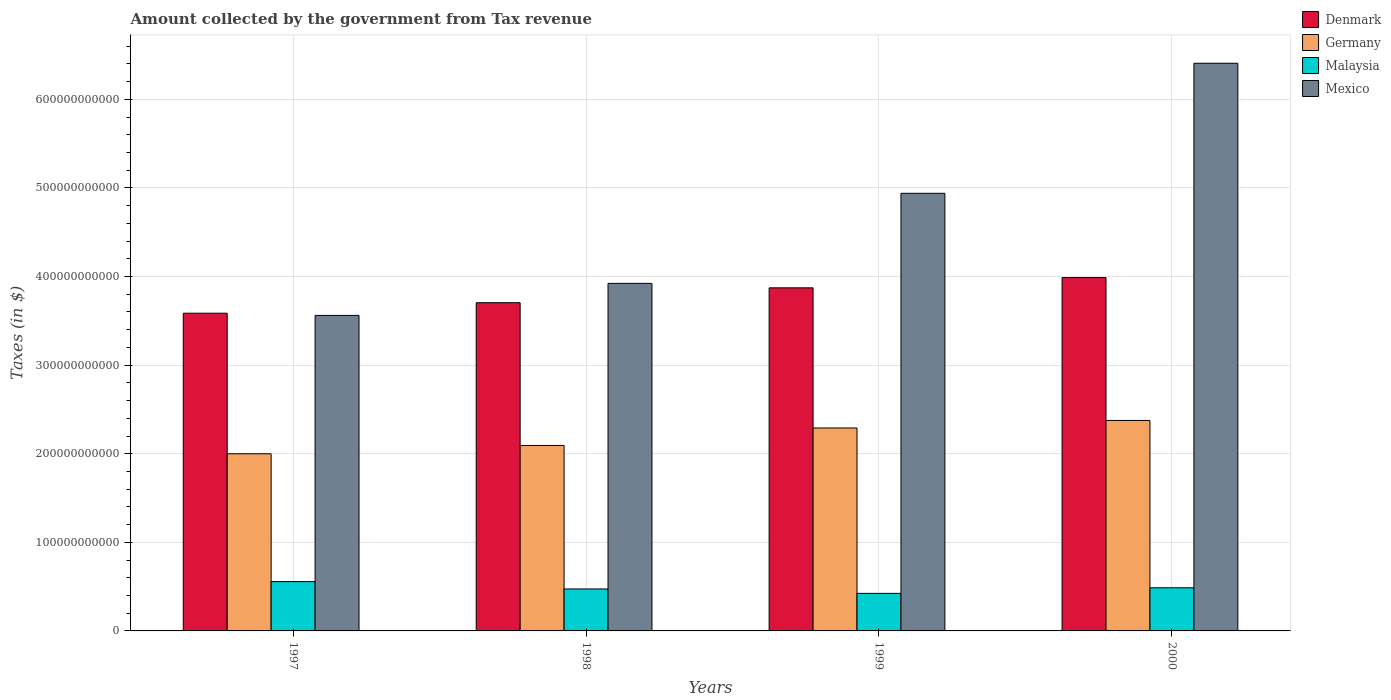How many groups of bars are there?
Your answer should be very brief. 4. Are the number of bars per tick equal to the number of legend labels?
Your answer should be very brief. Yes. Are the number of bars on each tick of the X-axis equal?
Give a very brief answer. Yes. How many bars are there on the 2nd tick from the right?
Provide a succinct answer. 4. What is the amount collected by the government from tax revenue in Mexico in 1997?
Your response must be concise. 3.56e+11. Across all years, what is the maximum amount collected by the government from tax revenue in Malaysia?
Give a very brief answer. 5.57e+1. Across all years, what is the minimum amount collected by the government from tax revenue in Malaysia?
Your answer should be compact. 4.24e+1. In which year was the amount collected by the government from tax revenue in Mexico minimum?
Ensure brevity in your answer.  1997. What is the total amount collected by the government from tax revenue in Mexico in the graph?
Your answer should be very brief. 1.88e+12. What is the difference between the amount collected by the government from tax revenue in Denmark in 1998 and that in 1999?
Provide a succinct answer. -1.68e+1. What is the difference between the amount collected by the government from tax revenue in Denmark in 1997 and the amount collected by the government from tax revenue in Malaysia in 1999?
Your response must be concise. 3.16e+11. What is the average amount collected by the government from tax revenue in Denmark per year?
Your answer should be very brief. 3.79e+11. In the year 1997, what is the difference between the amount collected by the government from tax revenue in Malaysia and amount collected by the government from tax revenue in Denmark?
Your answer should be very brief. -3.03e+11. What is the ratio of the amount collected by the government from tax revenue in Mexico in 1998 to that in 2000?
Offer a very short reply. 0.61. Is the difference between the amount collected by the government from tax revenue in Malaysia in 1997 and 2000 greater than the difference between the amount collected by the government from tax revenue in Denmark in 1997 and 2000?
Offer a terse response. Yes. What is the difference between the highest and the second highest amount collected by the government from tax revenue in Mexico?
Ensure brevity in your answer.  1.47e+11. What is the difference between the highest and the lowest amount collected by the government from tax revenue in Germany?
Provide a short and direct response. 3.76e+1. In how many years, is the amount collected by the government from tax revenue in Denmark greater than the average amount collected by the government from tax revenue in Denmark taken over all years?
Keep it short and to the point. 2. Is the sum of the amount collected by the government from tax revenue in Malaysia in 1999 and 2000 greater than the maximum amount collected by the government from tax revenue in Mexico across all years?
Offer a very short reply. No. What does the 4th bar from the left in 1998 represents?
Keep it short and to the point. Mexico. What does the 2nd bar from the right in 2000 represents?
Make the answer very short. Malaysia. Is it the case that in every year, the sum of the amount collected by the government from tax revenue in Denmark and amount collected by the government from tax revenue in Germany is greater than the amount collected by the government from tax revenue in Mexico?
Your answer should be compact. No. Are all the bars in the graph horizontal?
Offer a very short reply. No. What is the difference between two consecutive major ticks on the Y-axis?
Your answer should be compact. 1.00e+11. Does the graph contain grids?
Your response must be concise. Yes. Where does the legend appear in the graph?
Provide a succinct answer. Top right. How many legend labels are there?
Provide a succinct answer. 4. How are the legend labels stacked?
Give a very brief answer. Vertical. What is the title of the graph?
Provide a short and direct response. Amount collected by the government from Tax revenue. Does "Australia" appear as one of the legend labels in the graph?
Provide a short and direct response. No. What is the label or title of the X-axis?
Offer a very short reply. Years. What is the label or title of the Y-axis?
Your response must be concise. Taxes (in $). What is the Taxes (in $) in Denmark in 1997?
Offer a terse response. 3.59e+11. What is the Taxes (in $) of Germany in 1997?
Your answer should be very brief. 2.00e+11. What is the Taxes (in $) of Malaysia in 1997?
Give a very brief answer. 5.57e+1. What is the Taxes (in $) of Mexico in 1997?
Your answer should be compact. 3.56e+11. What is the Taxes (in $) in Denmark in 1998?
Your answer should be very brief. 3.70e+11. What is the Taxes (in $) in Germany in 1998?
Your answer should be very brief. 2.09e+11. What is the Taxes (in $) in Malaysia in 1998?
Give a very brief answer. 4.74e+1. What is the Taxes (in $) in Mexico in 1998?
Provide a succinct answer. 3.92e+11. What is the Taxes (in $) of Denmark in 1999?
Your answer should be compact. 3.87e+11. What is the Taxes (in $) in Germany in 1999?
Provide a short and direct response. 2.29e+11. What is the Taxes (in $) of Malaysia in 1999?
Your response must be concise. 4.24e+1. What is the Taxes (in $) in Mexico in 1999?
Your answer should be compact. 4.94e+11. What is the Taxes (in $) in Denmark in 2000?
Ensure brevity in your answer.  3.99e+11. What is the Taxes (in $) of Germany in 2000?
Offer a terse response. 2.38e+11. What is the Taxes (in $) in Malaysia in 2000?
Provide a succinct answer. 4.87e+1. What is the Taxes (in $) of Mexico in 2000?
Make the answer very short. 6.41e+11. Across all years, what is the maximum Taxes (in $) of Denmark?
Provide a succinct answer. 3.99e+11. Across all years, what is the maximum Taxes (in $) in Germany?
Your answer should be very brief. 2.38e+11. Across all years, what is the maximum Taxes (in $) in Malaysia?
Provide a short and direct response. 5.57e+1. Across all years, what is the maximum Taxes (in $) in Mexico?
Give a very brief answer. 6.41e+11. Across all years, what is the minimum Taxes (in $) in Denmark?
Your response must be concise. 3.59e+11. Across all years, what is the minimum Taxes (in $) of Germany?
Your answer should be compact. 2.00e+11. Across all years, what is the minimum Taxes (in $) in Malaysia?
Provide a short and direct response. 4.24e+1. Across all years, what is the minimum Taxes (in $) of Mexico?
Ensure brevity in your answer.  3.56e+11. What is the total Taxes (in $) in Denmark in the graph?
Give a very brief answer. 1.52e+12. What is the total Taxes (in $) in Germany in the graph?
Offer a terse response. 8.76e+11. What is the total Taxes (in $) in Malaysia in the graph?
Provide a succinct answer. 1.94e+11. What is the total Taxes (in $) in Mexico in the graph?
Provide a succinct answer. 1.88e+12. What is the difference between the Taxes (in $) of Denmark in 1997 and that in 1998?
Offer a terse response. -1.19e+1. What is the difference between the Taxes (in $) of Germany in 1997 and that in 1998?
Keep it short and to the point. -9.34e+09. What is the difference between the Taxes (in $) in Malaysia in 1997 and that in 1998?
Offer a terse response. 8.28e+09. What is the difference between the Taxes (in $) in Mexico in 1997 and that in 1998?
Your answer should be very brief. -3.62e+1. What is the difference between the Taxes (in $) in Denmark in 1997 and that in 1999?
Keep it short and to the point. -2.86e+1. What is the difference between the Taxes (in $) in Germany in 1997 and that in 1999?
Give a very brief answer. -2.91e+1. What is the difference between the Taxes (in $) in Malaysia in 1997 and that in 1999?
Your answer should be compact. 1.33e+1. What is the difference between the Taxes (in $) of Mexico in 1997 and that in 1999?
Provide a short and direct response. -1.38e+11. What is the difference between the Taxes (in $) in Denmark in 1997 and that in 2000?
Offer a very short reply. -4.02e+1. What is the difference between the Taxes (in $) in Germany in 1997 and that in 2000?
Provide a succinct answer. -3.76e+1. What is the difference between the Taxes (in $) of Malaysia in 1997 and that in 2000?
Give a very brief answer. 6.96e+09. What is the difference between the Taxes (in $) in Mexico in 1997 and that in 2000?
Your answer should be compact. -2.85e+11. What is the difference between the Taxes (in $) in Denmark in 1998 and that in 1999?
Make the answer very short. -1.68e+1. What is the difference between the Taxes (in $) of Germany in 1998 and that in 1999?
Offer a terse response. -1.98e+1. What is the difference between the Taxes (in $) of Malaysia in 1998 and that in 1999?
Ensure brevity in your answer.  5.00e+09. What is the difference between the Taxes (in $) of Mexico in 1998 and that in 1999?
Give a very brief answer. -1.02e+11. What is the difference between the Taxes (in $) of Denmark in 1998 and that in 2000?
Provide a succinct answer. -2.84e+1. What is the difference between the Taxes (in $) in Germany in 1998 and that in 2000?
Give a very brief answer. -2.83e+1. What is the difference between the Taxes (in $) in Malaysia in 1998 and that in 2000?
Offer a very short reply. -1.32e+09. What is the difference between the Taxes (in $) in Mexico in 1998 and that in 2000?
Keep it short and to the point. -2.48e+11. What is the difference between the Taxes (in $) in Denmark in 1999 and that in 2000?
Your answer should be compact. -1.16e+1. What is the difference between the Taxes (in $) of Germany in 1999 and that in 2000?
Keep it short and to the point. -8.50e+09. What is the difference between the Taxes (in $) in Malaysia in 1999 and that in 2000?
Provide a short and direct response. -6.32e+09. What is the difference between the Taxes (in $) of Mexico in 1999 and that in 2000?
Offer a very short reply. -1.47e+11. What is the difference between the Taxes (in $) of Denmark in 1997 and the Taxes (in $) of Germany in 1998?
Offer a terse response. 1.49e+11. What is the difference between the Taxes (in $) in Denmark in 1997 and the Taxes (in $) in Malaysia in 1998?
Your response must be concise. 3.11e+11. What is the difference between the Taxes (in $) of Denmark in 1997 and the Taxes (in $) of Mexico in 1998?
Your response must be concise. -3.37e+1. What is the difference between the Taxes (in $) in Germany in 1997 and the Taxes (in $) in Malaysia in 1998?
Provide a succinct answer. 1.53e+11. What is the difference between the Taxes (in $) in Germany in 1997 and the Taxes (in $) in Mexico in 1998?
Ensure brevity in your answer.  -1.92e+11. What is the difference between the Taxes (in $) of Malaysia in 1997 and the Taxes (in $) of Mexico in 1998?
Your answer should be compact. -3.37e+11. What is the difference between the Taxes (in $) of Denmark in 1997 and the Taxes (in $) of Germany in 1999?
Ensure brevity in your answer.  1.30e+11. What is the difference between the Taxes (in $) of Denmark in 1997 and the Taxes (in $) of Malaysia in 1999?
Give a very brief answer. 3.16e+11. What is the difference between the Taxes (in $) of Denmark in 1997 and the Taxes (in $) of Mexico in 1999?
Your answer should be compact. -1.35e+11. What is the difference between the Taxes (in $) of Germany in 1997 and the Taxes (in $) of Malaysia in 1999?
Give a very brief answer. 1.58e+11. What is the difference between the Taxes (in $) of Germany in 1997 and the Taxes (in $) of Mexico in 1999?
Your answer should be very brief. -2.94e+11. What is the difference between the Taxes (in $) in Malaysia in 1997 and the Taxes (in $) in Mexico in 1999?
Your answer should be compact. -4.38e+11. What is the difference between the Taxes (in $) of Denmark in 1997 and the Taxes (in $) of Germany in 2000?
Your answer should be very brief. 1.21e+11. What is the difference between the Taxes (in $) of Denmark in 1997 and the Taxes (in $) of Malaysia in 2000?
Ensure brevity in your answer.  3.10e+11. What is the difference between the Taxes (in $) in Denmark in 1997 and the Taxes (in $) in Mexico in 2000?
Provide a short and direct response. -2.82e+11. What is the difference between the Taxes (in $) of Germany in 1997 and the Taxes (in $) of Malaysia in 2000?
Offer a terse response. 1.51e+11. What is the difference between the Taxes (in $) in Germany in 1997 and the Taxes (in $) in Mexico in 2000?
Give a very brief answer. -4.41e+11. What is the difference between the Taxes (in $) of Malaysia in 1997 and the Taxes (in $) of Mexico in 2000?
Offer a very short reply. -5.85e+11. What is the difference between the Taxes (in $) in Denmark in 1998 and the Taxes (in $) in Germany in 1999?
Give a very brief answer. 1.41e+11. What is the difference between the Taxes (in $) of Denmark in 1998 and the Taxes (in $) of Malaysia in 1999?
Provide a succinct answer. 3.28e+11. What is the difference between the Taxes (in $) in Denmark in 1998 and the Taxes (in $) in Mexico in 1999?
Keep it short and to the point. -1.23e+11. What is the difference between the Taxes (in $) in Germany in 1998 and the Taxes (in $) in Malaysia in 1999?
Your answer should be compact. 1.67e+11. What is the difference between the Taxes (in $) of Germany in 1998 and the Taxes (in $) of Mexico in 1999?
Ensure brevity in your answer.  -2.85e+11. What is the difference between the Taxes (in $) of Malaysia in 1998 and the Taxes (in $) of Mexico in 1999?
Make the answer very short. -4.47e+11. What is the difference between the Taxes (in $) in Denmark in 1998 and the Taxes (in $) in Germany in 2000?
Provide a short and direct response. 1.33e+11. What is the difference between the Taxes (in $) in Denmark in 1998 and the Taxes (in $) in Malaysia in 2000?
Your response must be concise. 3.22e+11. What is the difference between the Taxes (in $) in Denmark in 1998 and the Taxes (in $) in Mexico in 2000?
Your answer should be compact. -2.70e+11. What is the difference between the Taxes (in $) in Germany in 1998 and the Taxes (in $) in Malaysia in 2000?
Provide a succinct answer. 1.61e+11. What is the difference between the Taxes (in $) of Germany in 1998 and the Taxes (in $) of Mexico in 2000?
Your answer should be compact. -4.31e+11. What is the difference between the Taxes (in $) of Malaysia in 1998 and the Taxes (in $) of Mexico in 2000?
Keep it short and to the point. -5.93e+11. What is the difference between the Taxes (in $) in Denmark in 1999 and the Taxes (in $) in Germany in 2000?
Give a very brief answer. 1.50e+11. What is the difference between the Taxes (in $) of Denmark in 1999 and the Taxes (in $) of Malaysia in 2000?
Provide a succinct answer. 3.39e+11. What is the difference between the Taxes (in $) in Denmark in 1999 and the Taxes (in $) in Mexico in 2000?
Offer a very short reply. -2.54e+11. What is the difference between the Taxes (in $) of Germany in 1999 and the Taxes (in $) of Malaysia in 2000?
Keep it short and to the point. 1.80e+11. What is the difference between the Taxes (in $) in Germany in 1999 and the Taxes (in $) in Mexico in 2000?
Your answer should be compact. -4.12e+11. What is the difference between the Taxes (in $) of Malaysia in 1999 and the Taxes (in $) of Mexico in 2000?
Keep it short and to the point. -5.98e+11. What is the average Taxes (in $) in Denmark per year?
Your answer should be compact. 3.79e+11. What is the average Taxes (in $) in Germany per year?
Your answer should be compact. 2.19e+11. What is the average Taxes (in $) in Malaysia per year?
Provide a short and direct response. 4.85e+1. What is the average Taxes (in $) in Mexico per year?
Make the answer very short. 4.71e+11. In the year 1997, what is the difference between the Taxes (in $) in Denmark and Taxes (in $) in Germany?
Provide a succinct answer. 1.59e+11. In the year 1997, what is the difference between the Taxes (in $) of Denmark and Taxes (in $) of Malaysia?
Ensure brevity in your answer.  3.03e+11. In the year 1997, what is the difference between the Taxes (in $) of Denmark and Taxes (in $) of Mexico?
Provide a succinct answer. 2.48e+09. In the year 1997, what is the difference between the Taxes (in $) in Germany and Taxes (in $) in Malaysia?
Give a very brief answer. 1.44e+11. In the year 1997, what is the difference between the Taxes (in $) of Germany and Taxes (in $) of Mexico?
Your answer should be very brief. -1.56e+11. In the year 1997, what is the difference between the Taxes (in $) in Malaysia and Taxes (in $) in Mexico?
Ensure brevity in your answer.  -3.00e+11. In the year 1998, what is the difference between the Taxes (in $) of Denmark and Taxes (in $) of Germany?
Keep it short and to the point. 1.61e+11. In the year 1998, what is the difference between the Taxes (in $) in Denmark and Taxes (in $) in Malaysia?
Provide a short and direct response. 3.23e+11. In the year 1998, what is the difference between the Taxes (in $) in Denmark and Taxes (in $) in Mexico?
Give a very brief answer. -2.18e+1. In the year 1998, what is the difference between the Taxes (in $) of Germany and Taxes (in $) of Malaysia?
Give a very brief answer. 1.62e+11. In the year 1998, what is the difference between the Taxes (in $) of Germany and Taxes (in $) of Mexico?
Offer a very short reply. -1.83e+11. In the year 1998, what is the difference between the Taxes (in $) in Malaysia and Taxes (in $) in Mexico?
Ensure brevity in your answer.  -3.45e+11. In the year 1999, what is the difference between the Taxes (in $) of Denmark and Taxes (in $) of Germany?
Ensure brevity in your answer.  1.58e+11. In the year 1999, what is the difference between the Taxes (in $) of Denmark and Taxes (in $) of Malaysia?
Offer a terse response. 3.45e+11. In the year 1999, what is the difference between the Taxes (in $) in Denmark and Taxes (in $) in Mexico?
Your answer should be very brief. -1.07e+11. In the year 1999, what is the difference between the Taxes (in $) in Germany and Taxes (in $) in Malaysia?
Your response must be concise. 1.87e+11. In the year 1999, what is the difference between the Taxes (in $) of Germany and Taxes (in $) of Mexico?
Give a very brief answer. -2.65e+11. In the year 1999, what is the difference between the Taxes (in $) of Malaysia and Taxes (in $) of Mexico?
Your answer should be very brief. -4.52e+11. In the year 2000, what is the difference between the Taxes (in $) in Denmark and Taxes (in $) in Germany?
Offer a very short reply. 1.61e+11. In the year 2000, what is the difference between the Taxes (in $) in Denmark and Taxes (in $) in Malaysia?
Ensure brevity in your answer.  3.50e+11. In the year 2000, what is the difference between the Taxes (in $) in Denmark and Taxes (in $) in Mexico?
Your answer should be compact. -2.42e+11. In the year 2000, what is the difference between the Taxes (in $) of Germany and Taxes (in $) of Malaysia?
Offer a very short reply. 1.89e+11. In the year 2000, what is the difference between the Taxes (in $) in Germany and Taxes (in $) in Mexico?
Keep it short and to the point. -4.03e+11. In the year 2000, what is the difference between the Taxes (in $) of Malaysia and Taxes (in $) of Mexico?
Ensure brevity in your answer.  -5.92e+11. What is the ratio of the Taxes (in $) of Germany in 1997 to that in 1998?
Give a very brief answer. 0.96. What is the ratio of the Taxes (in $) in Malaysia in 1997 to that in 1998?
Your answer should be compact. 1.17. What is the ratio of the Taxes (in $) in Mexico in 1997 to that in 1998?
Offer a terse response. 0.91. What is the ratio of the Taxes (in $) of Denmark in 1997 to that in 1999?
Make the answer very short. 0.93. What is the ratio of the Taxes (in $) of Germany in 1997 to that in 1999?
Your response must be concise. 0.87. What is the ratio of the Taxes (in $) of Malaysia in 1997 to that in 1999?
Your response must be concise. 1.31. What is the ratio of the Taxes (in $) in Mexico in 1997 to that in 1999?
Provide a short and direct response. 0.72. What is the ratio of the Taxes (in $) in Denmark in 1997 to that in 2000?
Your response must be concise. 0.9. What is the ratio of the Taxes (in $) in Germany in 1997 to that in 2000?
Offer a terse response. 0.84. What is the ratio of the Taxes (in $) of Malaysia in 1997 to that in 2000?
Make the answer very short. 1.14. What is the ratio of the Taxes (in $) of Mexico in 1997 to that in 2000?
Ensure brevity in your answer.  0.56. What is the ratio of the Taxes (in $) of Denmark in 1998 to that in 1999?
Provide a short and direct response. 0.96. What is the ratio of the Taxes (in $) in Germany in 1998 to that in 1999?
Your response must be concise. 0.91. What is the ratio of the Taxes (in $) of Malaysia in 1998 to that in 1999?
Your answer should be very brief. 1.12. What is the ratio of the Taxes (in $) in Mexico in 1998 to that in 1999?
Make the answer very short. 0.79. What is the ratio of the Taxes (in $) in Denmark in 1998 to that in 2000?
Keep it short and to the point. 0.93. What is the ratio of the Taxes (in $) of Germany in 1998 to that in 2000?
Make the answer very short. 0.88. What is the ratio of the Taxes (in $) in Malaysia in 1998 to that in 2000?
Ensure brevity in your answer.  0.97. What is the ratio of the Taxes (in $) in Mexico in 1998 to that in 2000?
Make the answer very short. 0.61. What is the ratio of the Taxes (in $) in Germany in 1999 to that in 2000?
Provide a succinct answer. 0.96. What is the ratio of the Taxes (in $) of Malaysia in 1999 to that in 2000?
Ensure brevity in your answer.  0.87. What is the ratio of the Taxes (in $) of Mexico in 1999 to that in 2000?
Make the answer very short. 0.77. What is the difference between the highest and the second highest Taxes (in $) of Denmark?
Keep it short and to the point. 1.16e+1. What is the difference between the highest and the second highest Taxes (in $) of Germany?
Keep it short and to the point. 8.50e+09. What is the difference between the highest and the second highest Taxes (in $) in Malaysia?
Provide a succinct answer. 6.96e+09. What is the difference between the highest and the second highest Taxes (in $) of Mexico?
Your answer should be compact. 1.47e+11. What is the difference between the highest and the lowest Taxes (in $) in Denmark?
Give a very brief answer. 4.02e+1. What is the difference between the highest and the lowest Taxes (in $) of Germany?
Offer a terse response. 3.76e+1. What is the difference between the highest and the lowest Taxes (in $) of Malaysia?
Make the answer very short. 1.33e+1. What is the difference between the highest and the lowest Taxes (in $) in Mexico?
Make the answer very short. 2.85e+11. 